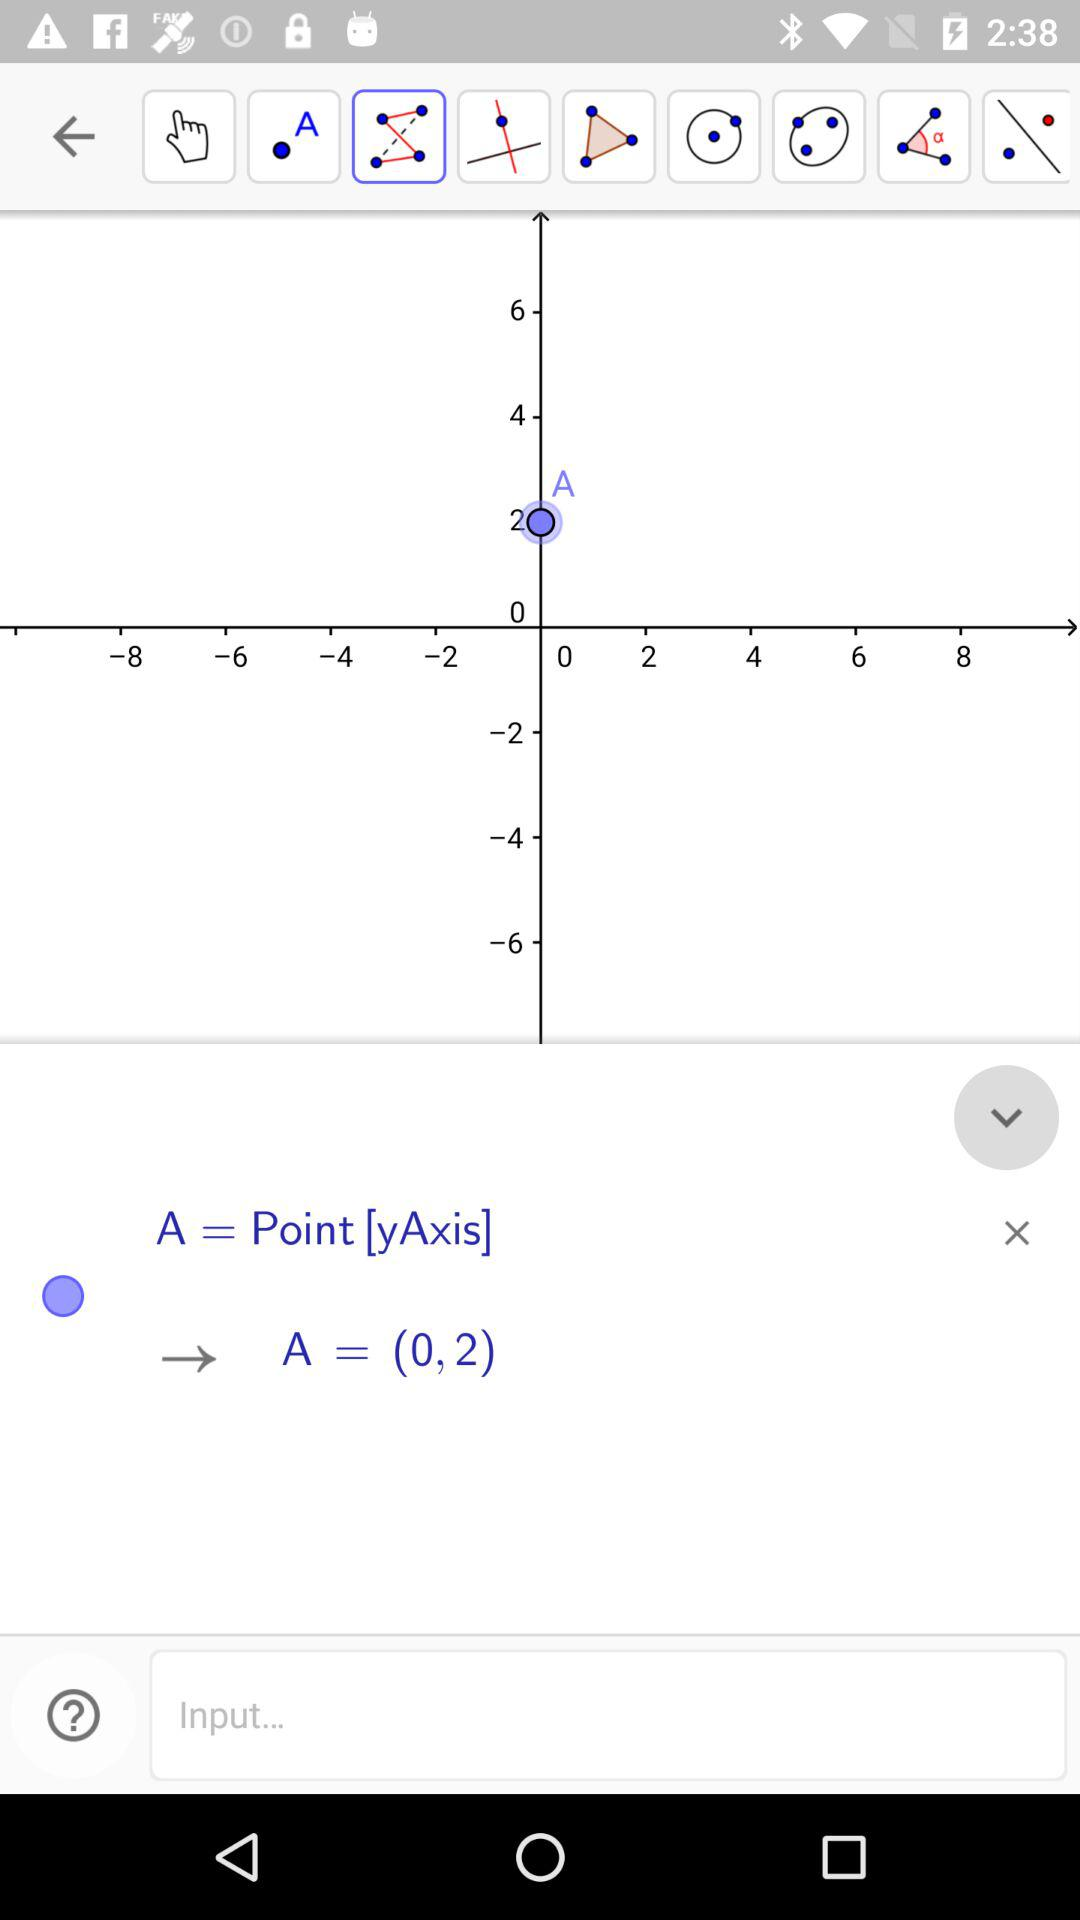What is the difference between the value of the text A and the value of the text 0?
Answer the question using a single word or phrase. 2 